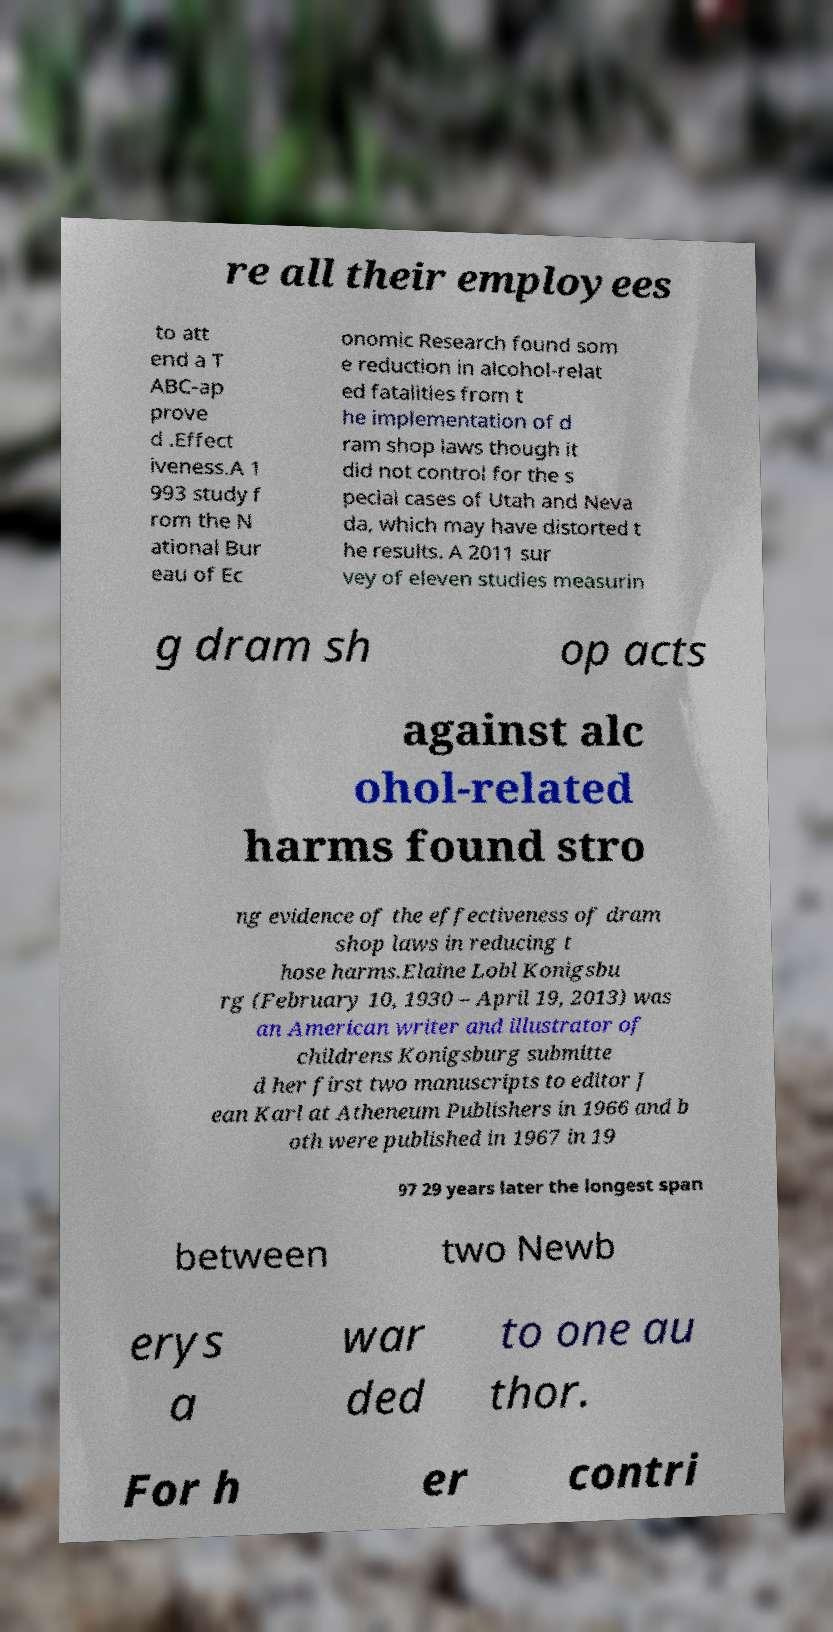Can you accurately transcribe the text from the provided image for me? re all their employees to att end a T ABC-ap prove d .Effect iveness.A 1 993 study f rom the N ational Bur eau of Ec onomic Research found som e reduction in alcohol-relat ed fatalities from t he implementation of d ram shop laws though it did not control for the s pecial cases of Utah and Neva da, which may have distorted t he results. A 2011 sur vey of eleven studies measurin g dram sh op acts against alc ohol-related harms found stro ng evidence of the effectiveness of dram shop laws in reducing t hose harms.Elaine Lobl Konigsbu rg (February 10, 1930 – April 19, 2013) was an American writer and illustrator of childrens Konigsburg submitte d her first two manuscripts to editor J ean Karl at Atheneum Publishers in 1966 and b oth were published in 1967 in 19 97 29 years later the longest span between two Newb erys a war ded to one au thor. For h er contri 